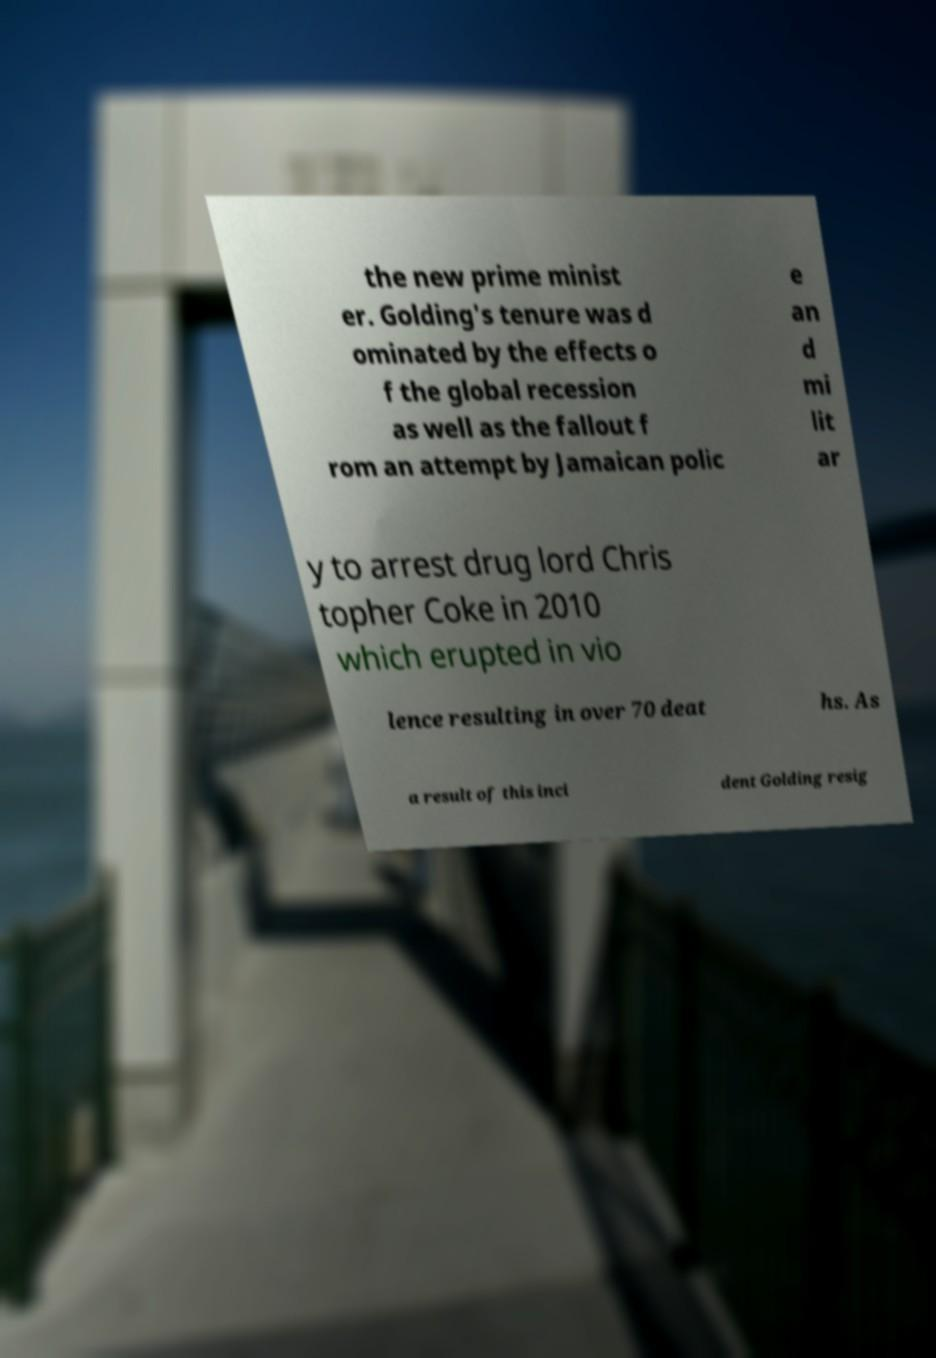What messages or text are displayed in this image? I need them in a readable, typed format. the new prime minist er. Golding's tenure was d ominated by the effects o f the global recession as well as the fallout f rom an attempt by Jamaican polic e an d mi lit ar y to arrest drug lord Chris topher Coke in 2010 which erupted in vio lence resulting in over 70 deat hs. As a result of this inci dent Golding resig 